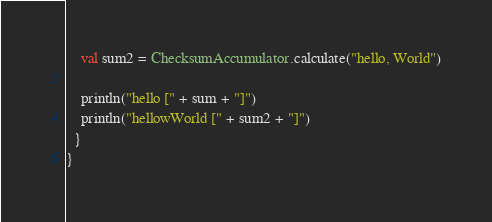<code> <loc_0><loc_0><loc_500><loc_500><_Scala_>    val sum2 = ChecksumAccumulator.calculate("hello, World")
    
    println("hello [" + sum + "]")
    println("hellowWorld [" + sum2 + "]")
  }
}</code> 